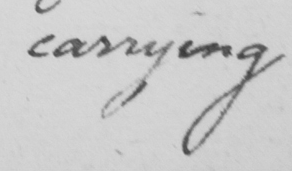Can you read and transcribe this handwriting? carrying 